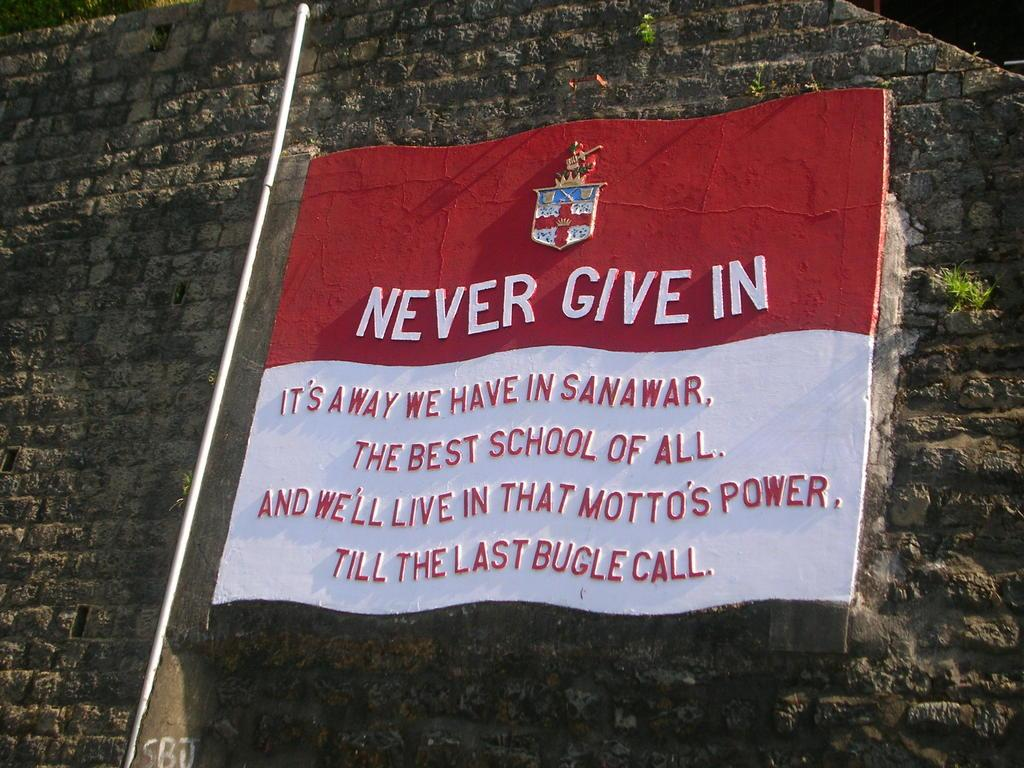What is the main object in the center of the image? There is a board in the center of the image on the wall. What is written or displayed on the board? There is some text on the board. Are there any other objects or features near the board? Yes, there is a pipe beside the board. Can you see any planes flying in the image? There are no planes visible in the image. What type of lead is being used to write the text on the board? There is no indication of any writing instrument being used, and the image does not show any lead. 